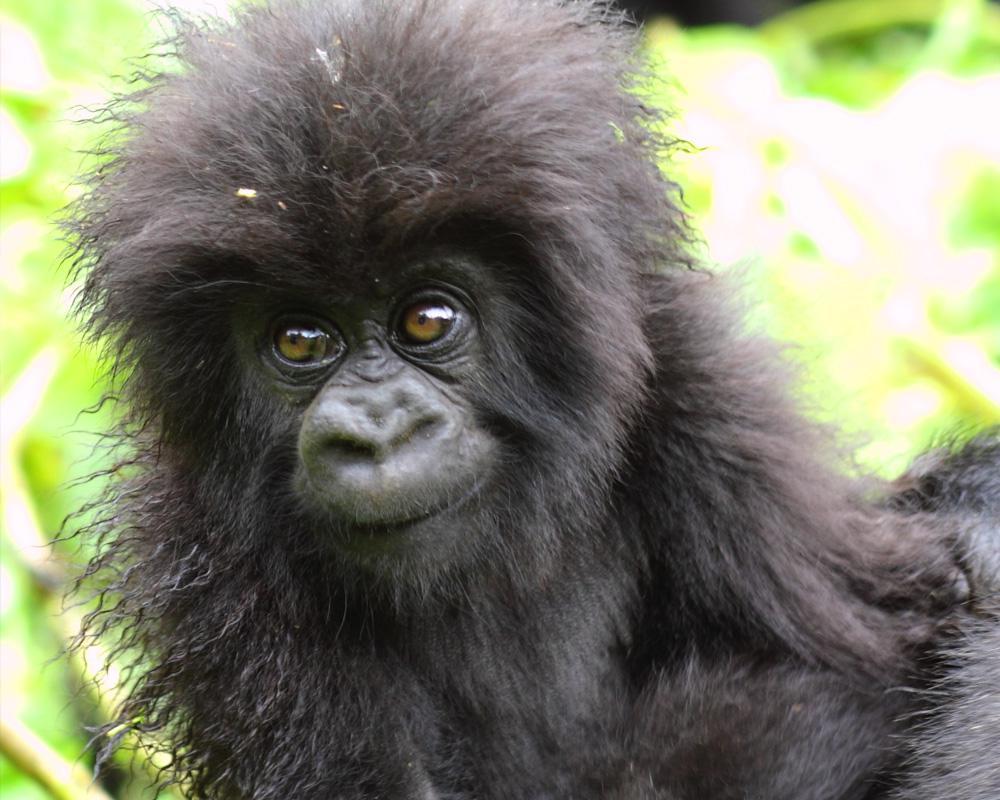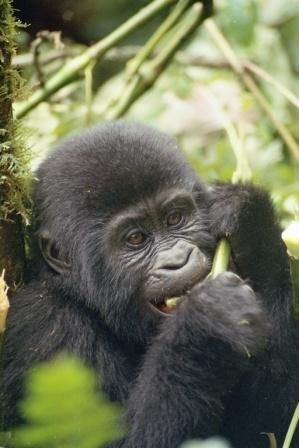The first image is the image on the left, the second image is the image on the right. Assess this claim about the two images: "In one of the image there is a baby gorilla next to an adult gorilla.". Correct or not? Answer yes or no. No. 